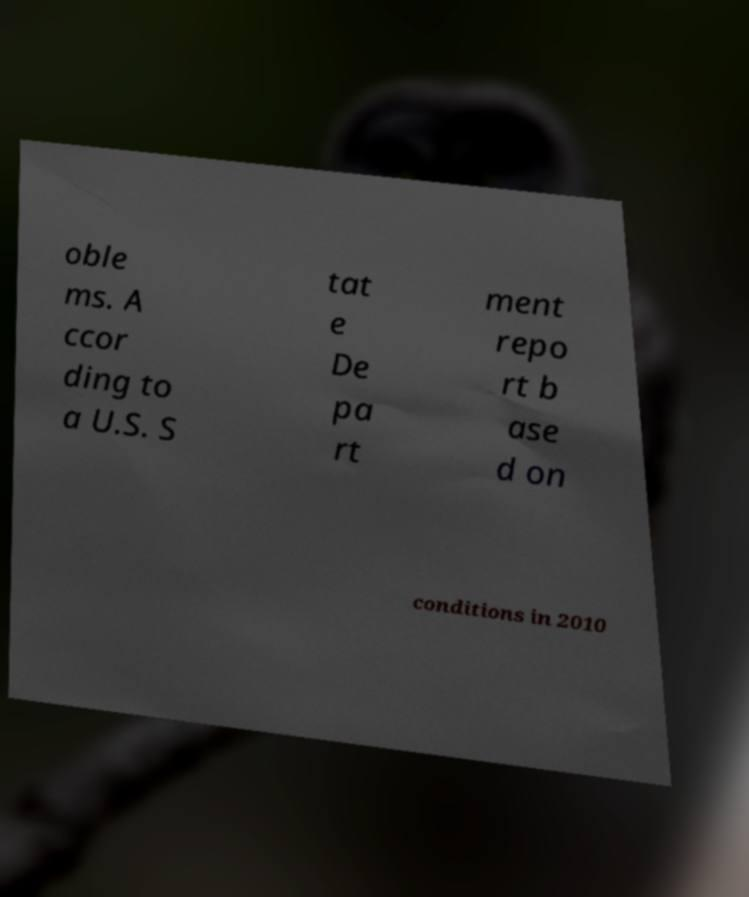Please identify and transcribe the text found in this image. oble ms. A ccor ding to a U.S. S tat e De pa rt ment repo rt b ase d on conditions in 2010 